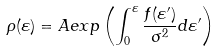<formula> <loc_0><loc_0><loc_500><loc_500>\rho ( \varepsilon ) = A e x p \left ( \int ^ { \varepsilon } _ { 0 } \frac { f ( \varepsilon ^ { \prime } ) } { \sigma ^ { 2 } } d \varepsilon ^ { \prime } \right )</formula> 